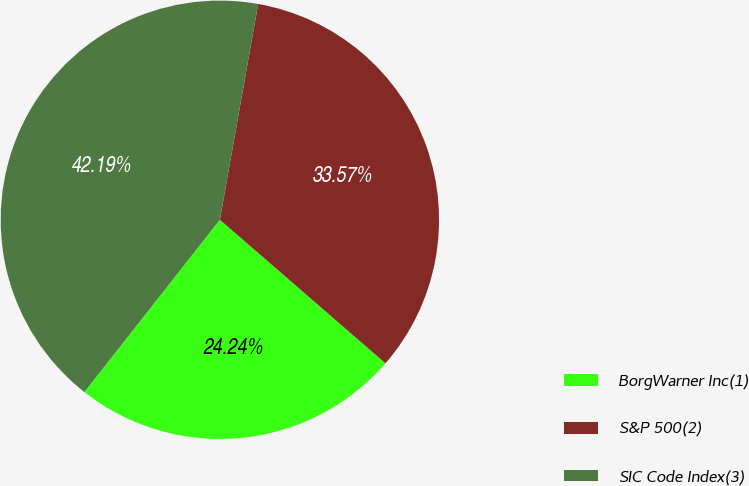Convert chart. <chart><loc_0><loc_0><loc_500><loc_500><pie_chart><fcel>BorgWarner Inc(1)<fcel>S&P 500(2)<fcel>SIC Code Index(3)<nl><fcel>24.24%<fcel>33.57%<fcel>42.19%<nl></chart> 